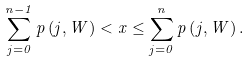Convert formula to latex. <formula><loc_0><loc_0><loc_500><loc_500>\sum _ { j = 0 } ^ { n - 1 } p \left ( j , W \right ) < x \leq \sum _ { j = 0 } ^ { n } p \left ( j , W \right ) .</formula> 